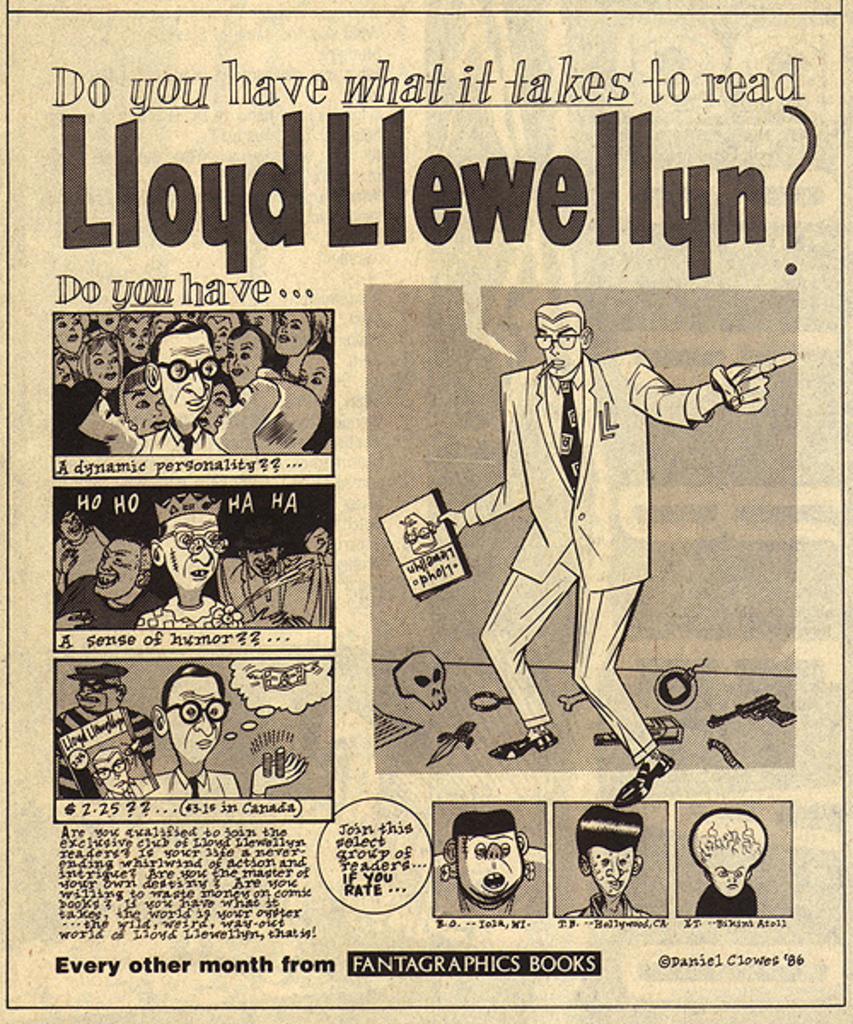Describe this image in one or two sentences. This is a poster and in this poster we can see some people, books and some text. 